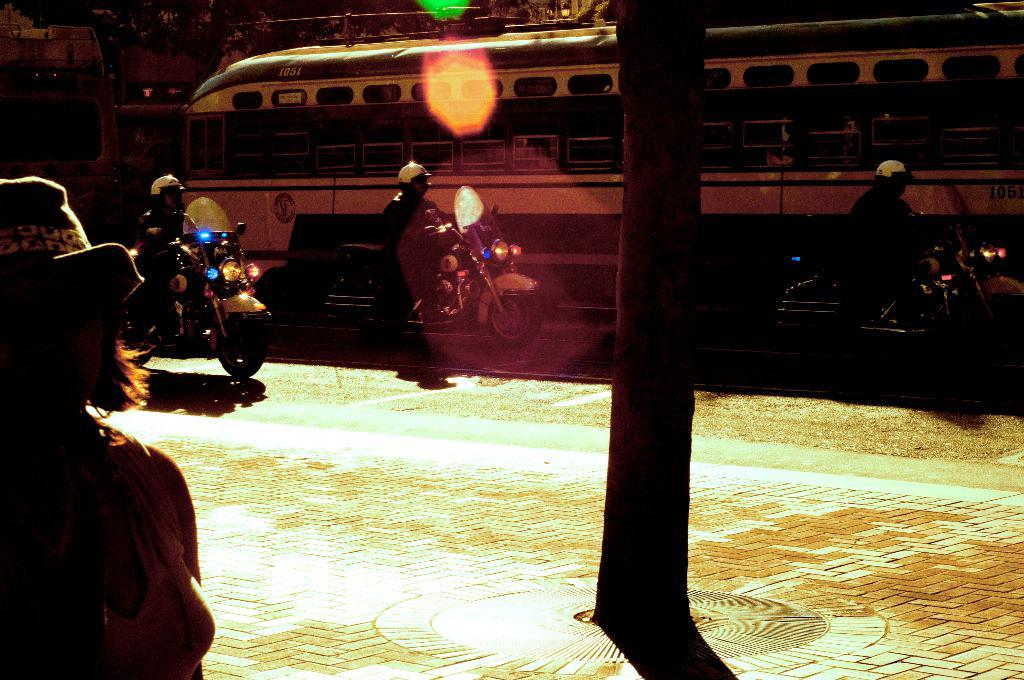How many people are in the image? There is a group of people in the image. What are some of the people doing in the image? Some people are riding bikes on the road. What other mode of transportation can be seen in the image? There is a train in the image. Can you describe any other objects in the image? There is a pole in the image. What color is the sheet hanging from the pole in the image? There is no sheet hanging from the pole in the image. How many crows are sitting on the train in the image? There are no crows present in the image. 